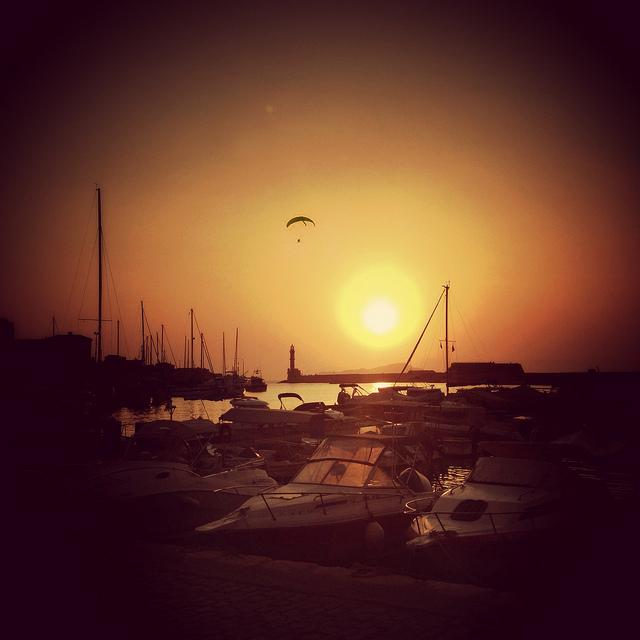This scene is likely to appear where? Please explain your reasoning. photographers portfolio. The picture is used for a portfolio. 